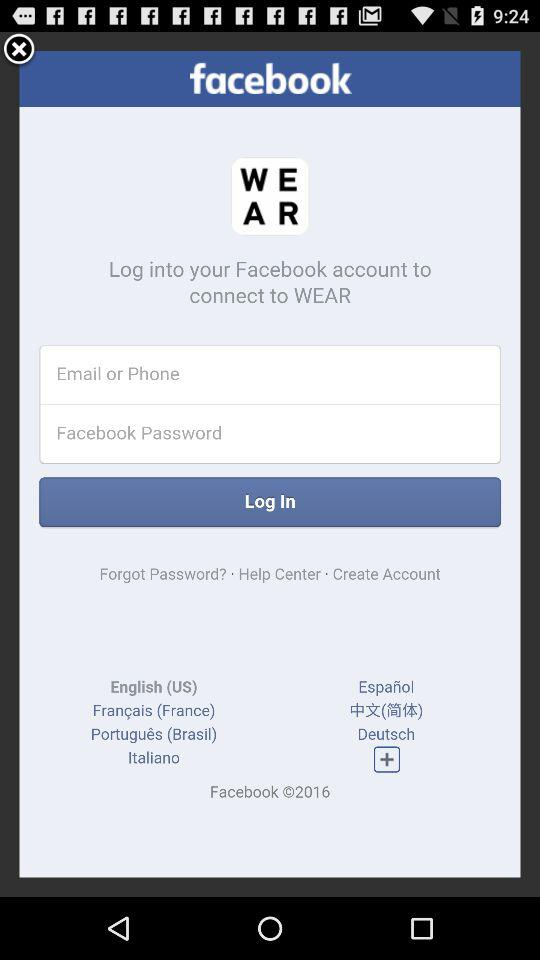To connect with what app, log in to your Facebook account? The app name is "WEAR". 